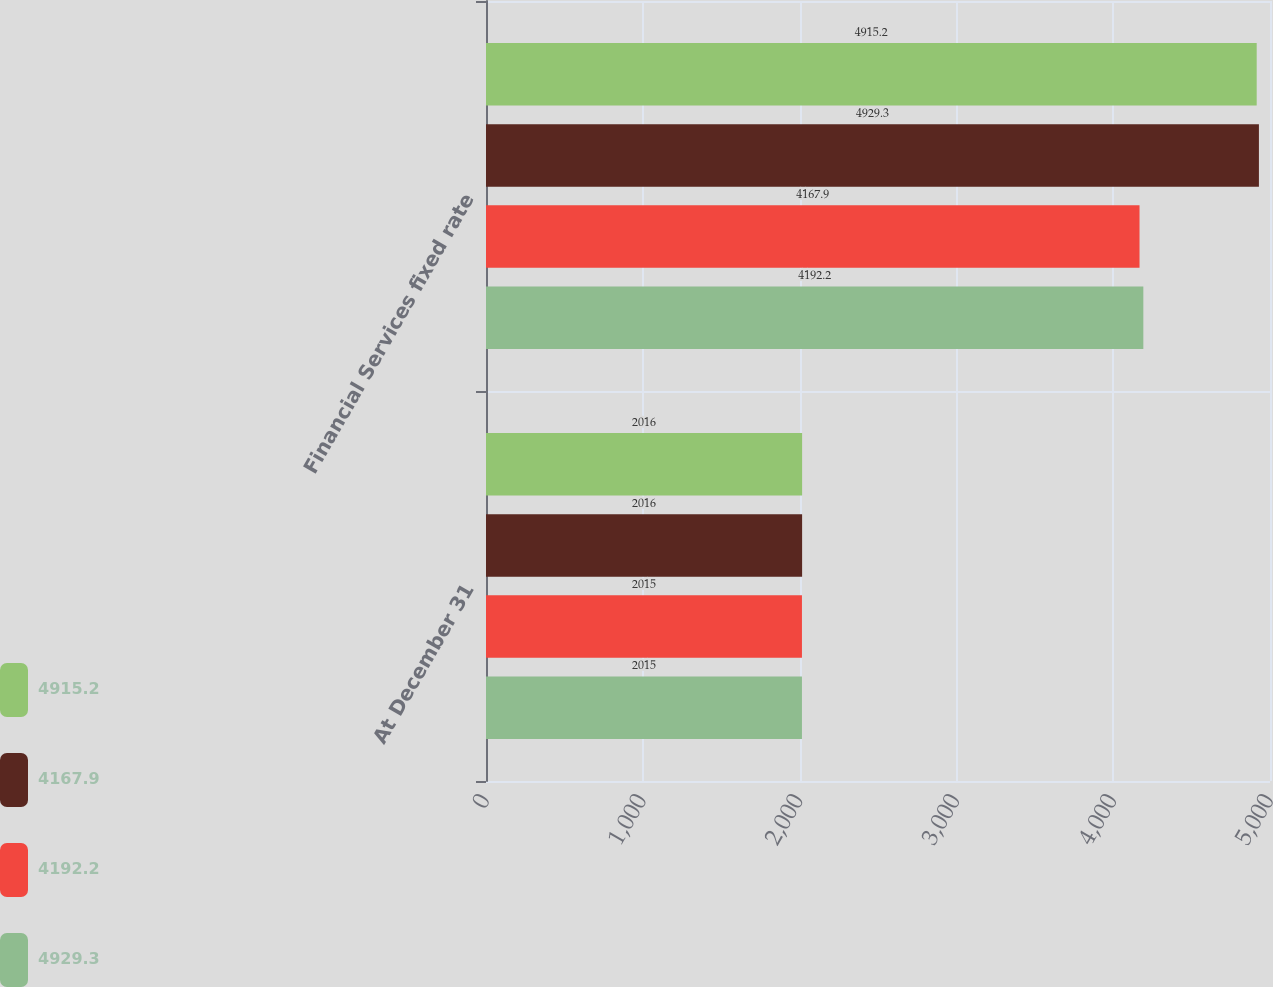Convert chart. <chart><loc_0><loc_0><loc_500><loc_500><stacked_bar_chart><ecel><fcel>At December 31<fcel>Financial Services fixed rate<nl><fcel>4915.2<fcel>2016<fcel>4915.2<nl><fcel>4167.9<fcel>2016<fcel>4929.3<nl><fcel>4192.2<fcel>2015<fcel>4167.9<nl><fcel>4929.3<fcel>2015<fcel>4192.2<nl></chart> 